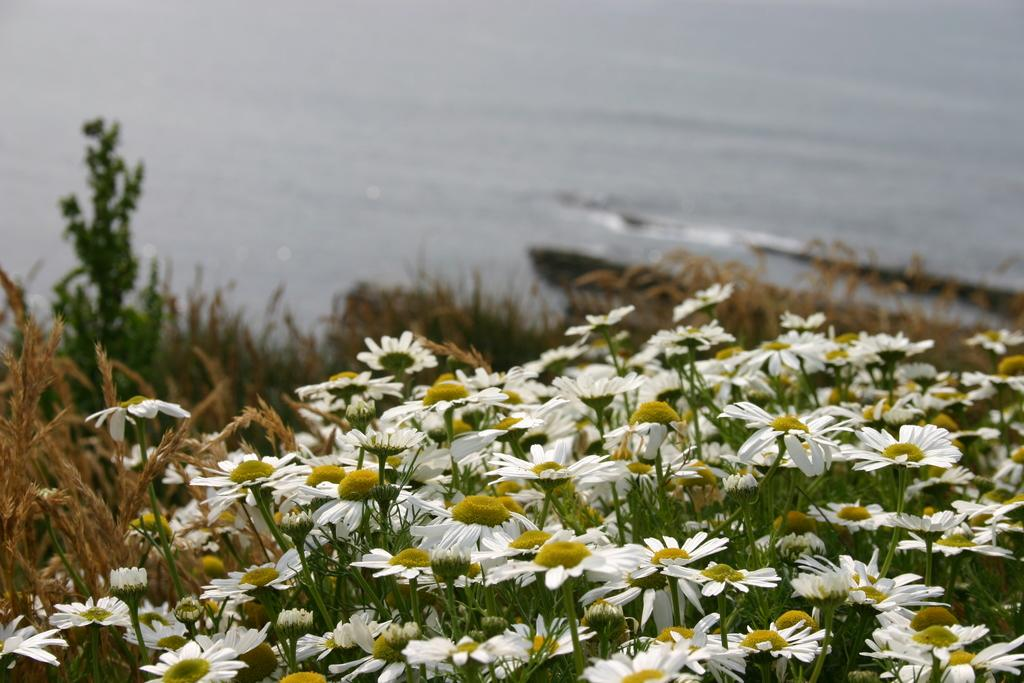What types of plants are in the foreground of the image? There are white flowers and other plants in the foreground of the image. What type of vegetation is present in the foreground of the image? There is grass in the foreground of the image. What can be seen at the top of the image? There appears to be water at the top of the image. What type of sweater is being worn by the squirrel in the image? There is no squirrel present in the image, and therefore no sweater can be observed. 